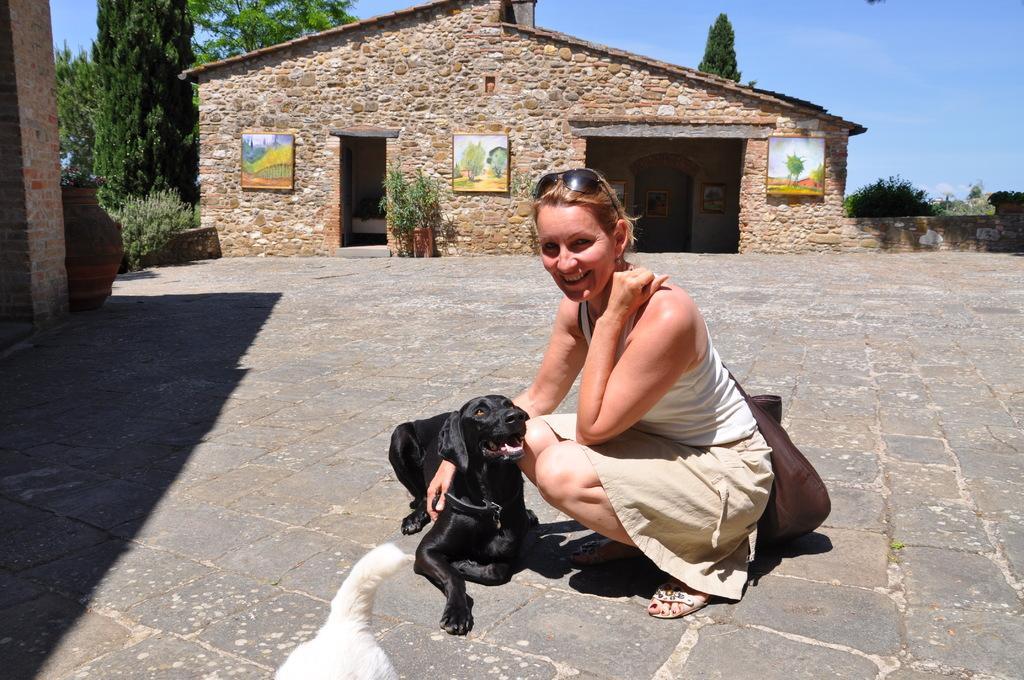In one or two sentences, can you explain what this image depicts? In this image we have a woman who is wearing a white color top and glasses on her head. She is smiling and she is sitting on the ground. Beside the women we have black color dog who is also sitting on the ground. Behind the woman we can see a house and a plant. Beside the house we can see a tree and on the left side of the image we have a blue sky. 